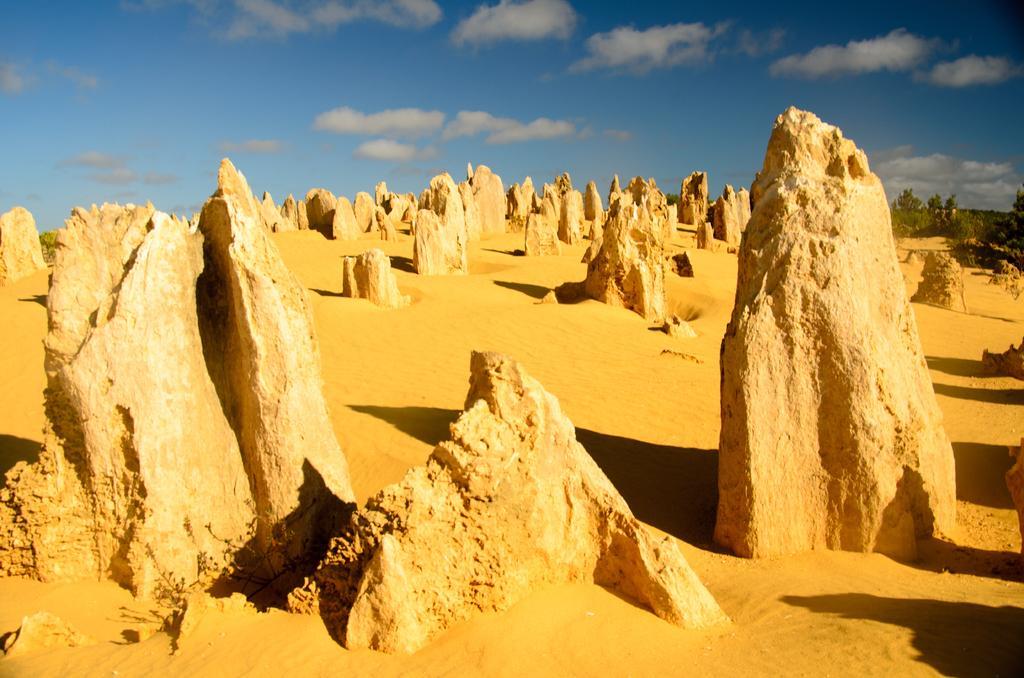Could you give a brief overview of what you see in this image? In this image there are big stones in the sand. On the right side top there are plants. At the top there is the sky. 